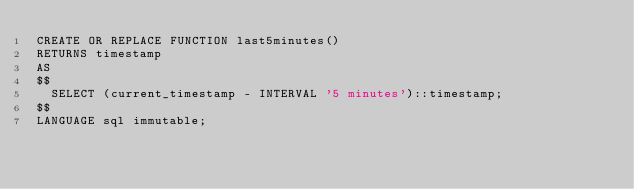<code> <loc_0><loc_0><loc_500><loc_500><_SQL_>CREATE OR REPLACE FUNCTION last5minutes()
RETURNS timestamp
AS
$$
  SELECT (current_timestamp - INTERVAL '5 minutes')::timestamp;
$$
LANGUAGE sql immutable;
</code> 